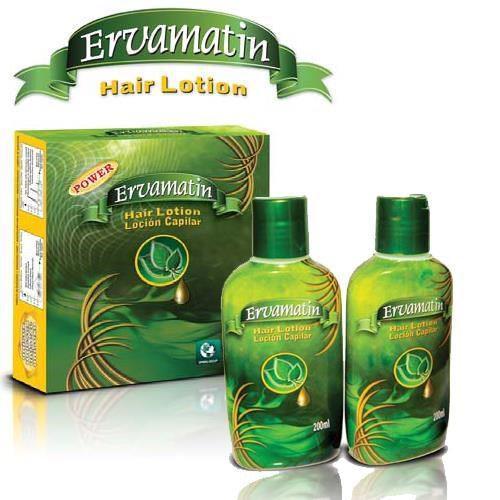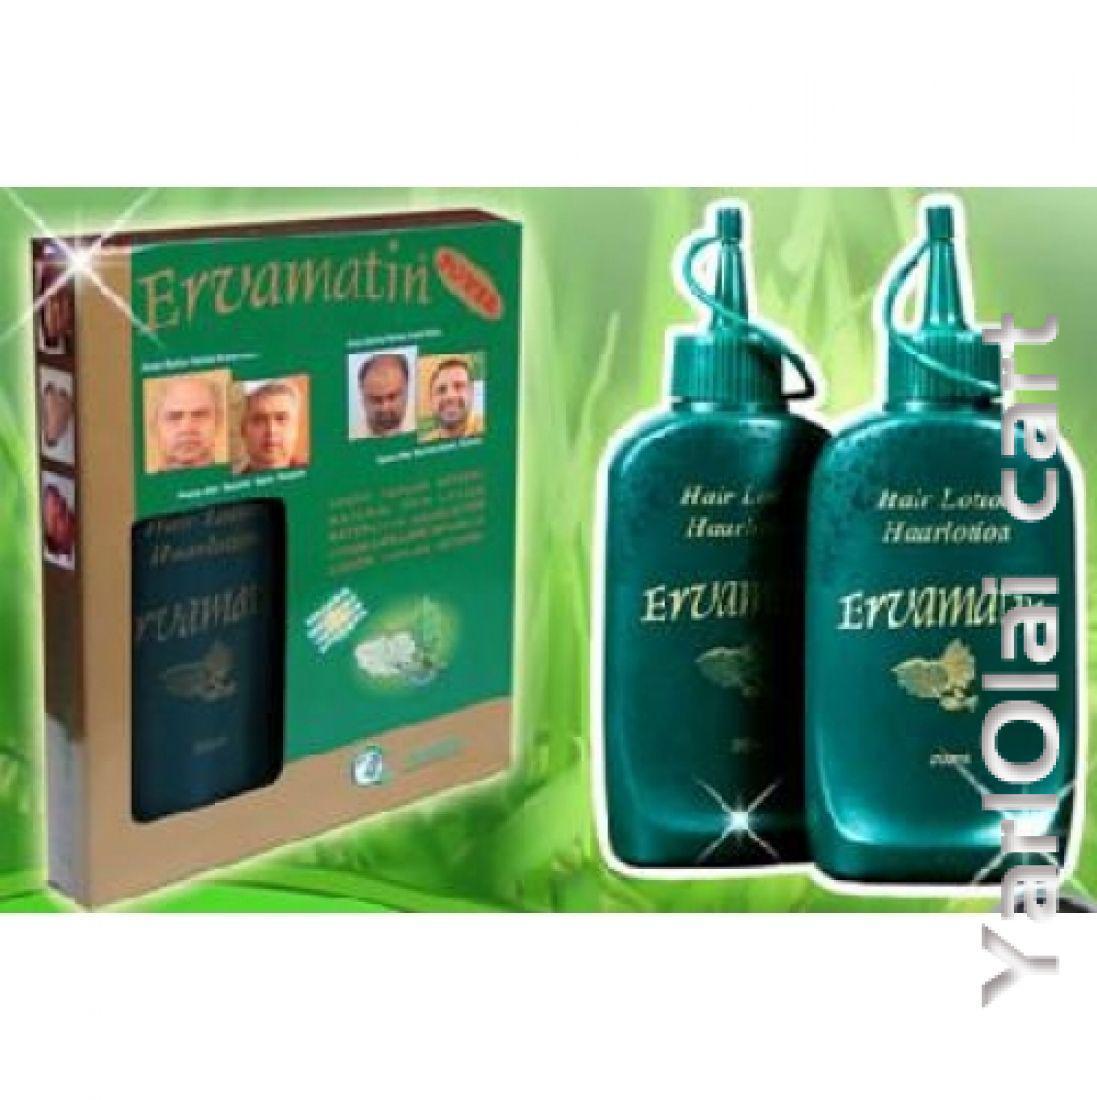The first image is the image on the left, the second image is the image on the right. Given the left and right images, does the statement "All of the bottles in the images are green." hold true? Answer yes or no. Yes. The first image is the image on the left, the second image is the image on the right. For the images shown, is this caption "A female has her hand touching her face, and an upright bottle overlaps the image." true? Answer yes or no. No. 